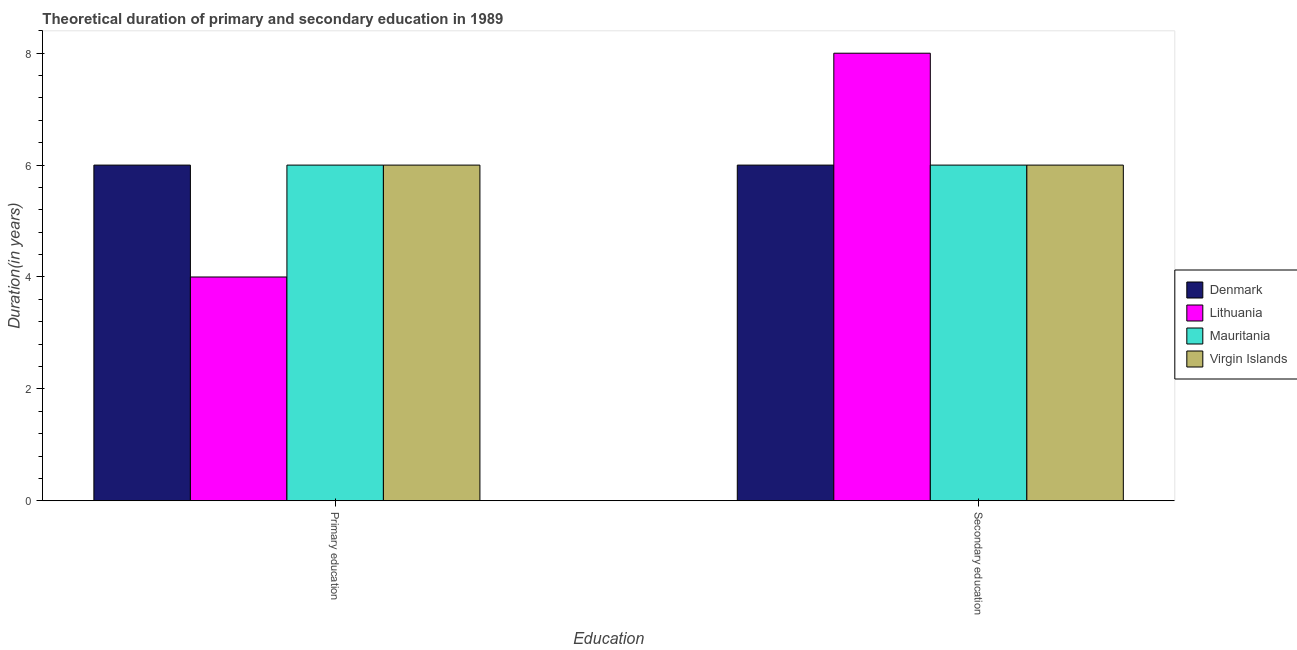How many bars are there on the 1st tick from the left?
Keep it short and to the point. 4. How many bars are there on the 2nd tick from the right?
Make the answer very short. 4. What is the label of the 1st group of bars from the left?
Offer a terse response. Primary education. What is the duration of secondary education in Mauritania?
Offer a very short reply. 6. Across all countries, what is the maximum duration of secondary education?
Provide a succinct answer. 8. Across all countries, what is the minimum duration of primary education?
Make the answer very short. 4. In which country was the duration of secondary education minimum?
Provide a succinct answer. Denmark. What is the total duration of secondary education in the graph?
Keep it short and to the point. 26. What is the difference between the duration of secondary education in Virgin Islands and that in Mauritania?
Your answer should be very brief. 0. What is the difference between the duration of secondary education in Virgin Islands and the duration of primary education in Lithuania?
Offer a terse response. 2. What is the average duration of secondary education per country?
Provide a short and direct response. 6.5. What is the difference between the duration of primary education and duration of secondary education in Lithuania?
Your response must be concise. -4. In how many countries, is the duration of secondary education greater than 4.4 years?
Ensure brevity in your answer.  4. What is the ratio of the duration of primary education in Virgin Islands to that in Mauritania?
Your response must be concise. 1. What does the 3rd bar from the left in Secondary education represents?
Ensure brevity in your answer.  Mauritania. What does the 1st bar from the right in Secondary education represents?
Keep it short and to the point. Virgin Islands. How many bars are there?
Offer a very short reply. 8. How many countries are there in the graph?
Your answer should be compact. 4. Does the graph contain any zero values?
Your answer should be compact. No. Does the graph contain grids?
Give a very brief answer. No. What is the title of the graph?
Your answer should be very brief. Theoretical duration of primary and secondary education in 1989. Does "Guyana" appear as one of the legend labels in the graph?
Give a very brief answer. No. What is the label or title of the X-axis?
Make the answer very short. Education. What is the label or title of the Y-axis?
Your response must be concise. Duration(in years). What is the Duration(in years) of Lithuania in Primary education?
Offer a very short reply. 4. What is the Duration(in years) of Virgin Islands in Primary education?
Provide a short and direct response. 6. What is the Duration(in years) in Lithuania in Secondary education?
Your response must be concise. 8. What is the Duration(in years) in Mauritania in Secondary education?
Your response must be concise. 6. Across all Education, what is the maximum Duration(in years) of Denmark?
Provide a succinct answer. 6. Across all Education, what is the minimum Duration(in years) of Virgin Islands?
Give a very brief answer. 6. What is the total Duration(in years) in Denmark in the graph?
Give a very brief answer. 12. What is the total Duration(in years) in Lithuania in the graph?
Your response must be concise. 12. What is the total Duration(in years) in Mauritania in the graph?
Make the answer very short. 12. What is the total Duration(in years) of Virgin Islands in the graph?
Your response must be concise. 12. What is the difference between the Duration(in years) of Lithuania in Primary education and that in Secondary education?
Provide a succinct answer. -4. What is the difference between the Duration(in years) of Denmark in Primary education and the Duration(in years) of Virgin Islands in Secondary education?
Make the answer very short. 0. What is the difference between the Duration(in years) of Lithuania in Primary education and the Duration(in years) of Virgin Islands in Secondary education?
Provide a short and direct response. -2. What is the difference between the Duration(in years) of Mauritania in Primary education and the Duration(in years) of Virgin Islands in Secondary education?
Provide a short and direct response. 0. What is the average Duration(in years) in Mauritania per Education?
Ensure brevity in your answer.  6. What is the average Duration(in years) of Virgin Islands per Education?
Your answer should be compact. 6. What is the difference between the Duration(in years) in Denmark and Duration(in years) in Lithuania in Primary education?
Make the answer very short. 2. What is the difference between the Duration(in years) of Lithuania and Duration(in years) of Virgin Islands in Primary education?
Your answer should be compact. -2. What is the difference between the Duration(in years) in Denmark and Duration(in years) in Mauritania in Secondary education?
Provide a short and direct response. 0. What is the difference between the Duration(in years) in Denmark and Duration(in years) in Virgin Islands in Secondary education?
Offer a very short reply. 0. What is the difference between the Duration(in years) of Lithuania and Duration(in years) of Virgin Islands in Secondary education?
Offer a very short reply. 2. What is the ratio of the Duration(in years) of Denmark in Primary education to that in Secondary education?
Your response must be concise. 1. What is the ratio of the Duration(in years) in Lithuania in Primary education to that in Secondary education?
Keep it short and to the point. 0.5. What is the ratio of the Duration(in years) of Mauritania in Primary education to that in Secondary education?
Your answer should be compact. 1. What is the ratio of the Duration(in years) in Virgin Islands in Primary education to that in Secondary education?
Offer a very short reply. 1. What is the difference between the highest and the second highest Duration(in years) in Denmark?
Your answer should be compact. 0. What is the difference between the highest and the second highest Duration(in years) of Lithuania?
Your response must be concise. 4. What is the difference between the highest and the second highest Duration(in years) of Virgin Islands?
Make the answer very short. 0. What is the difference between the highest and the lowest Duration(in years) in Denmark?
Provide a short and direct response. 0. What is the difference between the highest and the lowest Duration(in years) of Virgin Islands?
Offer a very short reply. 0. 